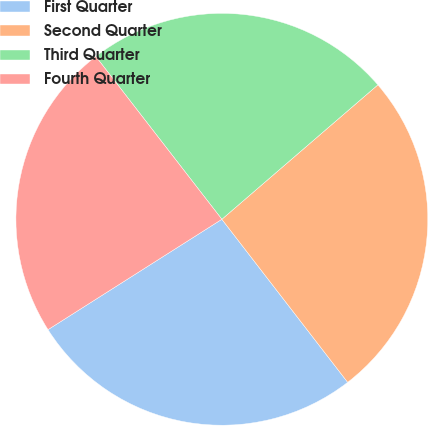Convert chart to OTSL. <chart><loc_0><loc_0><loc_500><loc_500><pie_chart><fcel>First Quarter<fcel>Second Quarter<fcel>Third Quarter<fcel>Fourth Quarter<nl><fcel>26.46%<fcel>25.86%<fcel>24.17%<fcel>23.52%<nl></chart> 